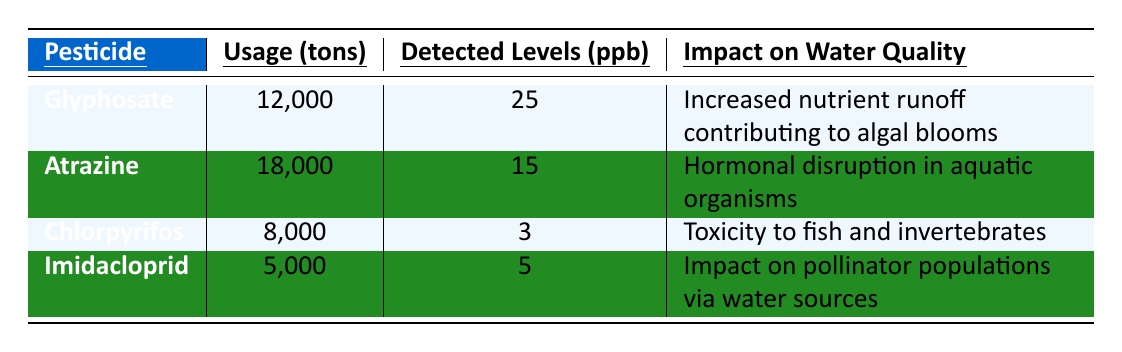What is the usage of Glyphosate in tons? The table lists the usage of Glyphosate under the "Usage (tons)" column, where it is stated to be 12,000 tons.
Answer: 12,000 tons Which pesticide has the highest detected levels in ppb? By comparing the values in the "Detected Levels (ppb)" column, Glyphosate has the highest level at 25 ppb.
Answer: Glyphosate What is the impact of Atrazine on water quality? The impact of Atrazine is specified in the "Impact on Water Quality" column, stating it causes hormonal disruption in aquatic organisms.
Answer: Hormonal disruption in aquatic organisms Is the threshold for Nitrogen levels exceeded? The table indicates that the threshold for Nitrogen Levels (mg/L) is marked as "Yes," meaning it exceeded the acceptable level.
Answer: Yes What is the average usage of the four listed pesticides? The average usage can be calculated by summing the usages (12,000 + 18,000 + 8,000 + 5,000) = 43,000 tons, then dividing by the number of pesticides (4), which gives 43,000 / 4 = 10,750 tons.
Answer: 10,750 tons How many pesticides have an impact related to aquatic life? Checking the "Impact on Water Quality" column, both Atrazine and Chlorpyrifos indicate impacts related to aquatic organisms (hormonal disruption and toxicity). Thus, there are two pesticides.
Answer: 2 Which pesticide has the lowest detected levels in ppb? The "Detected Levels (ppb)" column shows that Chlorpyrifos has the lowest level at 3 ppb.
Answer: Chlorpyrifos What is the average detected level of the pesticides listed? To find the average, sum the detected levels (25 + 15 + 3 + 5) = 48 ppb, then divide by the number of pesticides (4), giving 48 / 4 = 12 ppb.
Answer: 12 ppb Which pesticide has a reported impact on pollinator populations? Imidacloprid is specified under the "Impact on Water Quality" column as having an impact on pollinator populations via water sources.
Answer: Imidacloprid If Atrazine usage were to decrease by 3,000 tons, what would its new usage be? The current usage of Atrazine is 18,000 tons, so subtracting 3,000 gives 18,000 - 3,000 = 15,000 tons.
Answer: 15,000 tons 